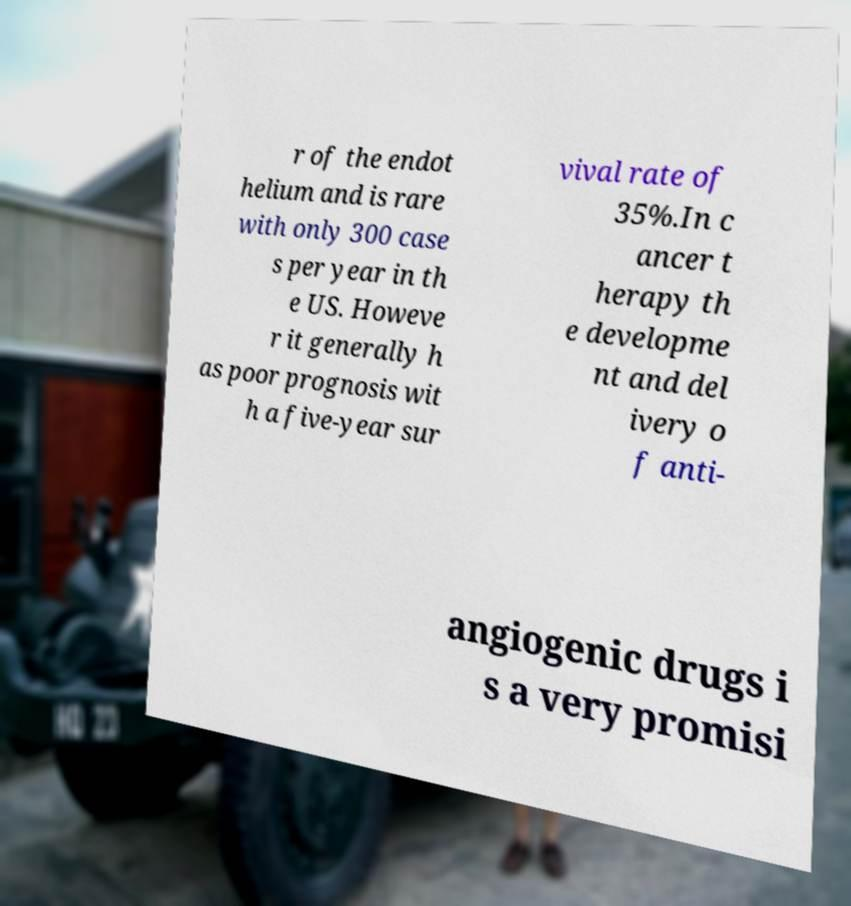What messages or text are displayed in this image? I need them in a readable, typed format. r of the endot helium and is rare with only 300 case s per year in th e US. Howeve r it generally h as poor prognosis wit h a five-year sur vival rate of 35%.In c ancer t herapy th e developme nt and del ivery o f anti- angiogenic drugs i s a very promisi 